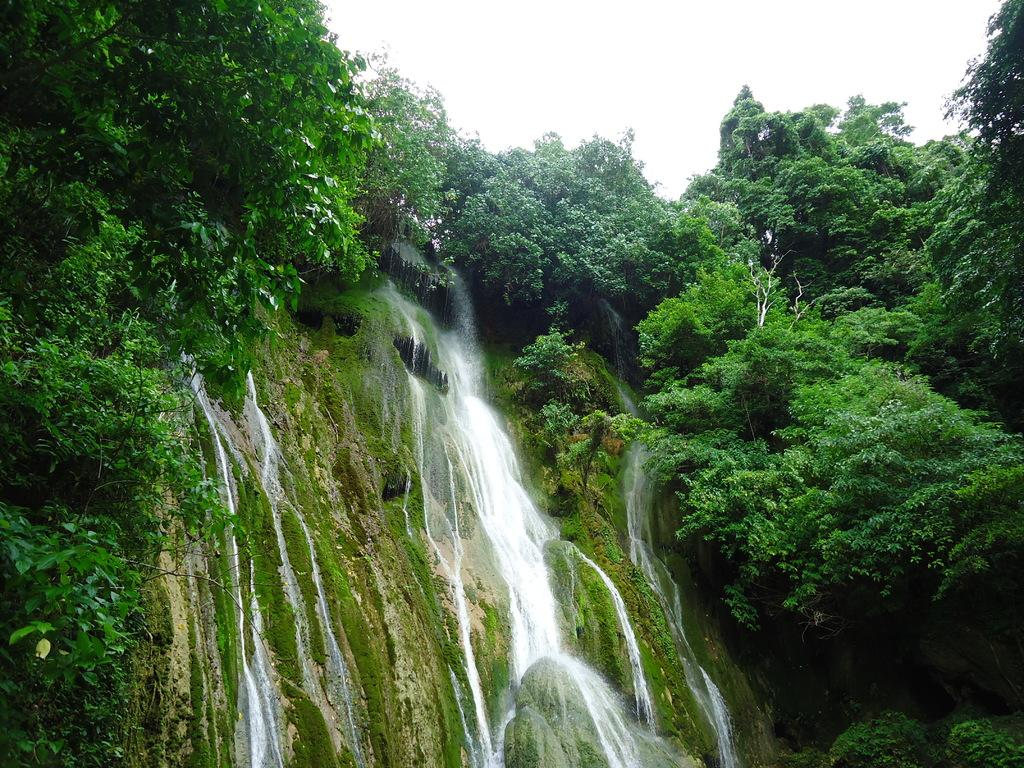What natural feature is the main subject of the image? There is a waterfall in the image. What type of environment surrounds the waterfall? There are trees around the waterfall, resembling a forest. What can be seen in the background of the image? The sky is visible in the image. What topic is being discussed by the waterfall in the image? There is no discussion taking place in the image, as the waterfall is a natural feature and cannot engage in discussions. 